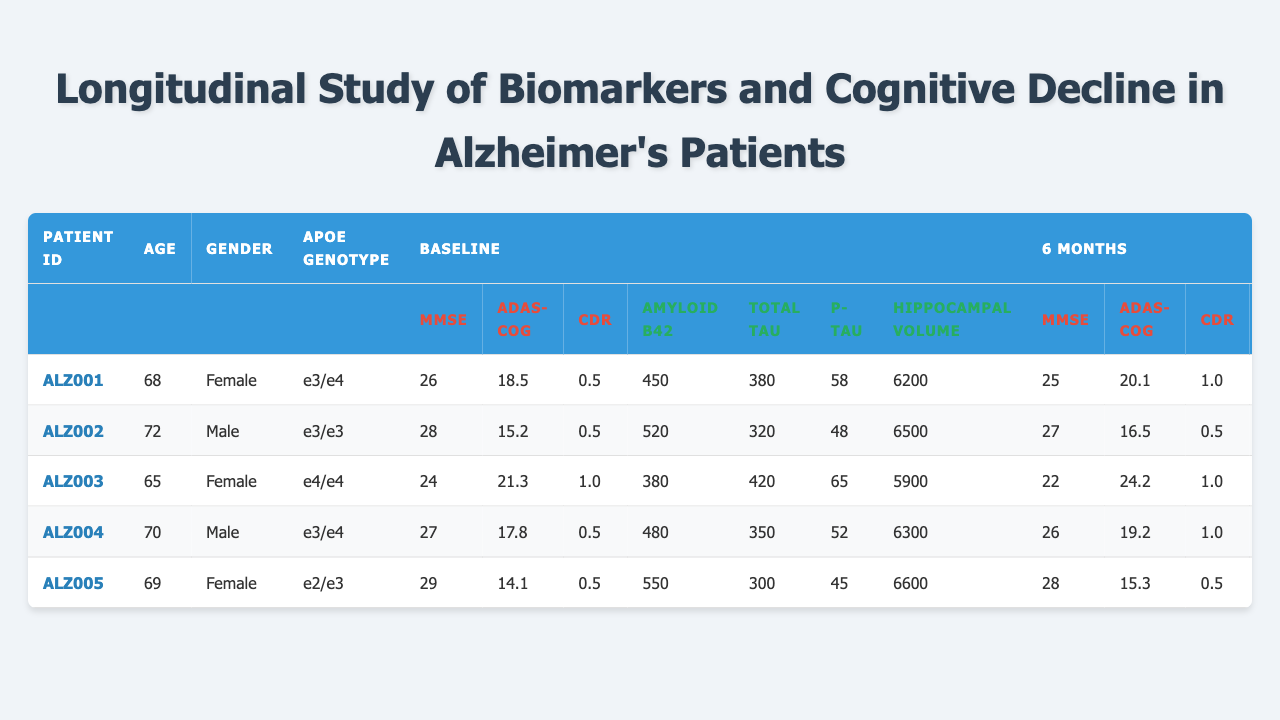What is the age of patient ALZ003? The table shows patient ALZ003 has an age of 65.
Answer: 65 What is the gender of patient ALZ002? In the table, it is indicated that patient ALZ002 is Male.
Answer: Male What was the baseline MMSE score for patient ALZ005? The table states that the baseline MMSE score for patient ALZ005 is 29.
Answer: 29 What is the 12-month hippocampal volume for patient ALZ001? Looking at the table, patient ALZ001 has a 12-month hippocampal volume of 5900.
Answer: 5900 Did patient ALZ004's ADAS-Cog score increase from baseline to 12 months? By comparing the table, the baseline ADAS-Cog score is 17.8, and the 12-month score is 21.7, indicating an increase.
Answer: Yes Which patient had the highest baseline total tau score? The table shows patient ALZ003 had a baseline total tau score of 420, which is the highest among all patients listed.
Answer: ALZ003 What is the average age of the patients in the study? The sum of the ages is 68 + 72 + 65 + 70 + 69 = 344. There are 5 patients, so the average age is 344/5 = 68.8.
Answer: 68.8 What was the smallest change in the MMSE score from baseline to 6 months among the patients? For each patient, the change from baseline to 6 months is calculated: ALZ001 (1), ALZ002 (1), ALZ003 (2), ALZ004 (1), ALZ005 (1). The smallest change is 1.
Answer: 1 Is patient ALZ004's APOE genotype e3/e4? The table shows that patient ALZ004 has the APOE genotype e3/e4, confirming this fact.
Answer: Yes Who had the lowest 6-month CDR score? Comparing the 6-month CDR scores in the table, patient ALZ002 has the lowest score of 0.5.
Answer: ALZ002 What is the difference in amyloid beta 42 levels from baseline to 12 months for patient ALZ003? For patient ALZ003, baseline amyloid beta 42 is 380 and at 12 months is 320. The difference is 380 - 320 = 60.
Answer: 60 Which patient had the highest 12-month ADAS-Cog score? The table notes that patient ALZ003 had the highest 12-month ADAS-Cog score of 28.5.
Answer: ALZ003 How many patients had a 6-month CDR score of 1.0? Looking through the table, ALZ001, ALZ003, and ALZ004 each had a 6-month CDR score of 1.0, so there are 3 patients.
Answer: 3 What is the trend observed for the hippocampal volume in patient ALZ002 over 12 months? Patient ALZ002 began with a hippocampal volume of 6500 at baseline and decreased to 6250 at 12 months, indicating a decline over the year.
Answer: Declined What average total tau score did the patients have at baseline? The sum of baseline total tau scores is 380 + 320 + 420 + 350 + 300 = 1770. The average is 1770/5 = 354.
Answer: 354 